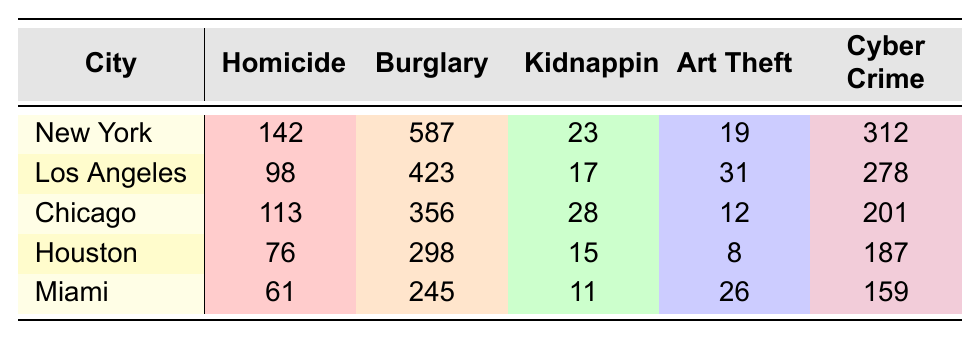What city has the highest number of unsolved homicide cases? Looking at the "Homicide" column, New York has 142 unsolved cases, which is greater than any other city listed.
Answer: New York Which city has the least unsolved cases for Art Theft? By checking the "Art Theft" column, Houston has the lowest unsolved cases, with a total of 8.
Answer: Houston What is the total number of unsolved burglary cases across all cities? Adding the burglary cases: 587 (New York) + 423 (Los Angeles) + 356 (Chicago) + 298 (Houston) + 245 (Miami) gives a total of 1909 unsolved burglary cases.
Answer: 1909 For which crime type does Los Angeles have the most unsolved cases? In the Los Angeles row, the crime type with the highest number of unsolved cases is Burglary, with 423 cases.
Answer: Burglary Is the number of unsolved kidnapping cases in Chicago higher than that in Miami? Chicago has 28 unsolved kidnapping cases, while Miami has 11. Since 28 is greater than 11, the statement is true.
Answer: Yes What is the average number of unsolved cyber crime cases across all cities? To find the average, add the cyber crime cases: 312 (New York) + 278 (Los Angeles) + 201 (Chicago) + 187 (Houston) + 159 (Miami) = 1137. Then divide by 5, the number of cities: 1137 / 5 = 227.4.
Answer: 227.4 Which city has the highest total number of unsolved cases across all crime types? Calculate the total unsolved cases for each city: New York (142 + 587 + 23 + 19 + 312 = 1083), Los Angeles (98 + 423 + 17 + 31 + 278 = 847), Chicago (113 + 356 + 28 + 12 + 201 = 710), Houston (76 + 298 + 15 + 8 + 187 = 584), Miami (61 + 245 + 11 + 26 + 159 = 502). New York has the highest total at 1083.
Answer: New York How many more unsolved kidnapping cases does New York have compared to Houston? New York has 23 unsolved cases while Houston has 15. The difference is 23 - 15 = 8.
Answer: 8 If we consider only the crime type Cyber Crime, which city has the most and what is the value? The Cyber Crime column shows New York with 312 cases, which is more than any other city.
Answer: New York, 312 Is the total number of unsolved homicide cases in Chicago greater than that of Miami? Chicago has 113 unsolved homicide cases, and Miami has 61. Since 113 is greater than 61, the answer is yes.
Answer: Yes 